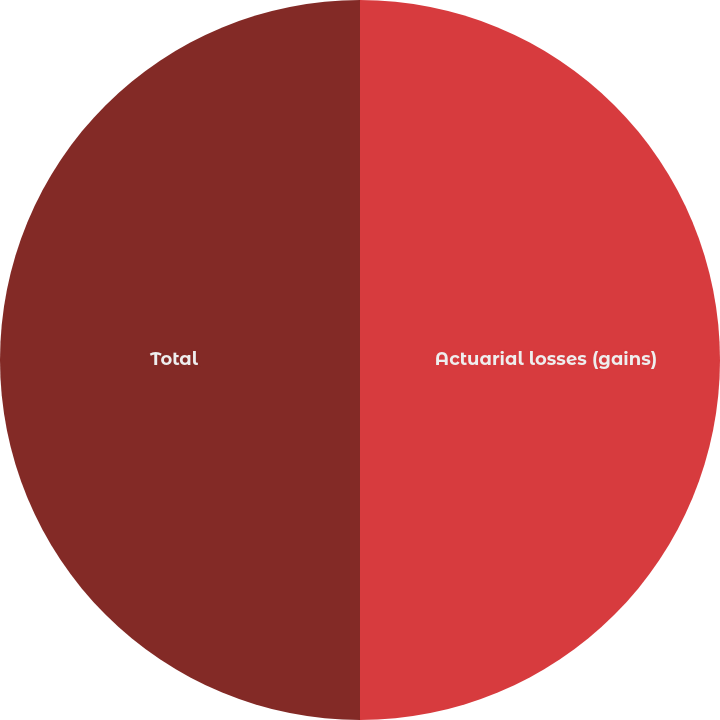<chart> <loc_0><loc_0><loc_500><loc_500><pie_chart><fcel>Actuarial losses (gains)<fcel>Total<nl><fcel>50.0%<fcel>50.0%<nl></chart> 